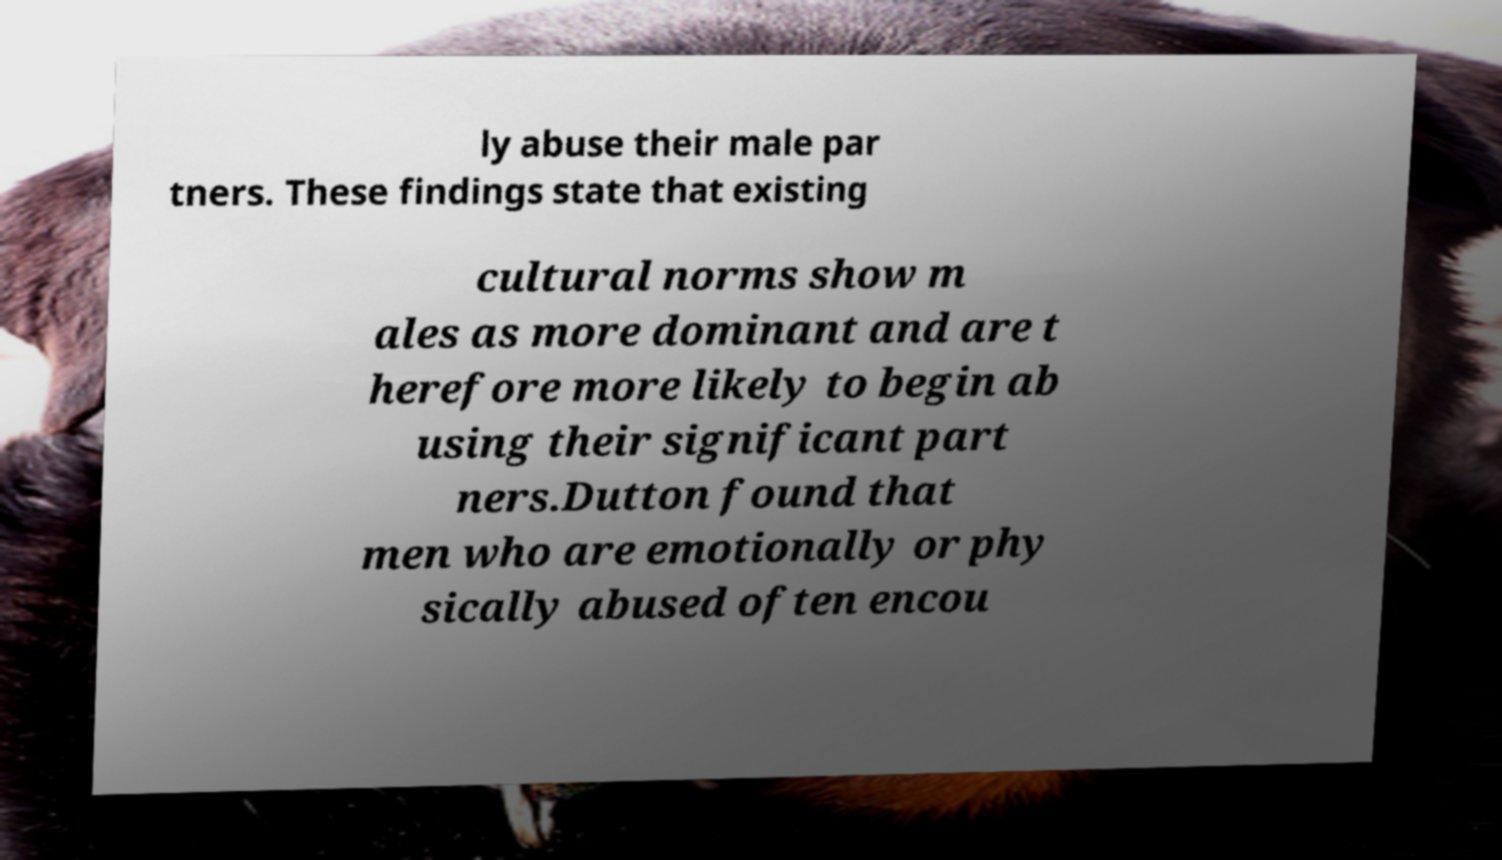Can you accurately transcribe the text from the provided image for me? ly abuse their male par tners. These findings state that existing cultural norms show m ales as more dominant and are t herefore more likely to begin ab using their significant part ners.Dutton found that men who are emotionally or phy sically abused often encou 